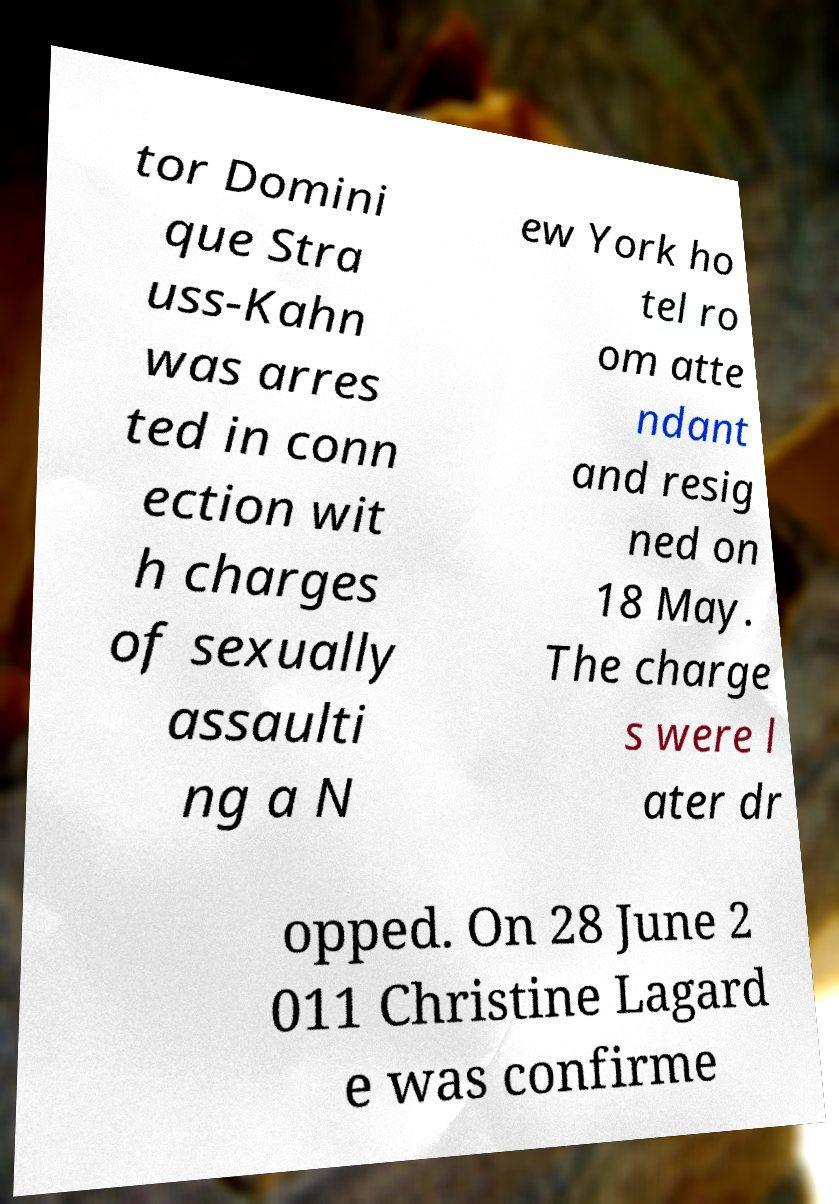Can you accurately transcribe the text from the provided image for me? tor Domini que Stra uss-Kahn was arres ted in conn ection wit h charges of sexually assaulti ng a N ew York ho tel ro om atte ndant and resig ned on 18 May. The charge s were l ater dr opped. On 28 June 2 011 Christine Lagard e was confirme 